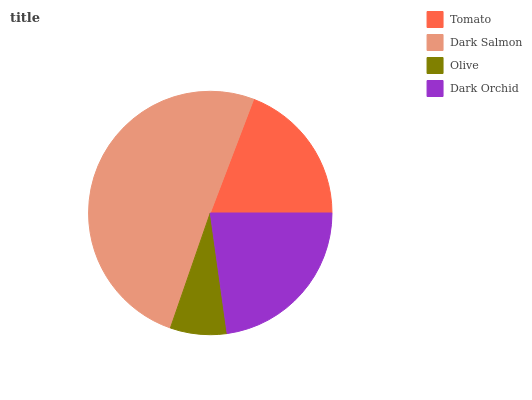Is Olive the minimum?
Answer yes or no. Yes. Is Dark Salmon the maximum?
Answer yes or no. Yes. Is Dark Salmon the minimum?
Answer yes or no. No. Is Olive the maximum?
Answer yes or no. No. Is Dark Salmon greater than Olive?
Answer yes or no. Yes. Is Olive less than Dark Salmon?
Answer yes or no. Yes. Is Olive greater than Dark Salmon?
Answer yes or no. No. Is Dark Salmon less than Olive?
Answer yes or no. No. Is Dark Orchid the high median?
Answer yes or no. Yes. Is Tomato the low median?
Answer yes or no. Yes. Is Tomato the high median?
Answer yes or no. No. Is Dark Orchid the low median?
Answer yes or no. No. 